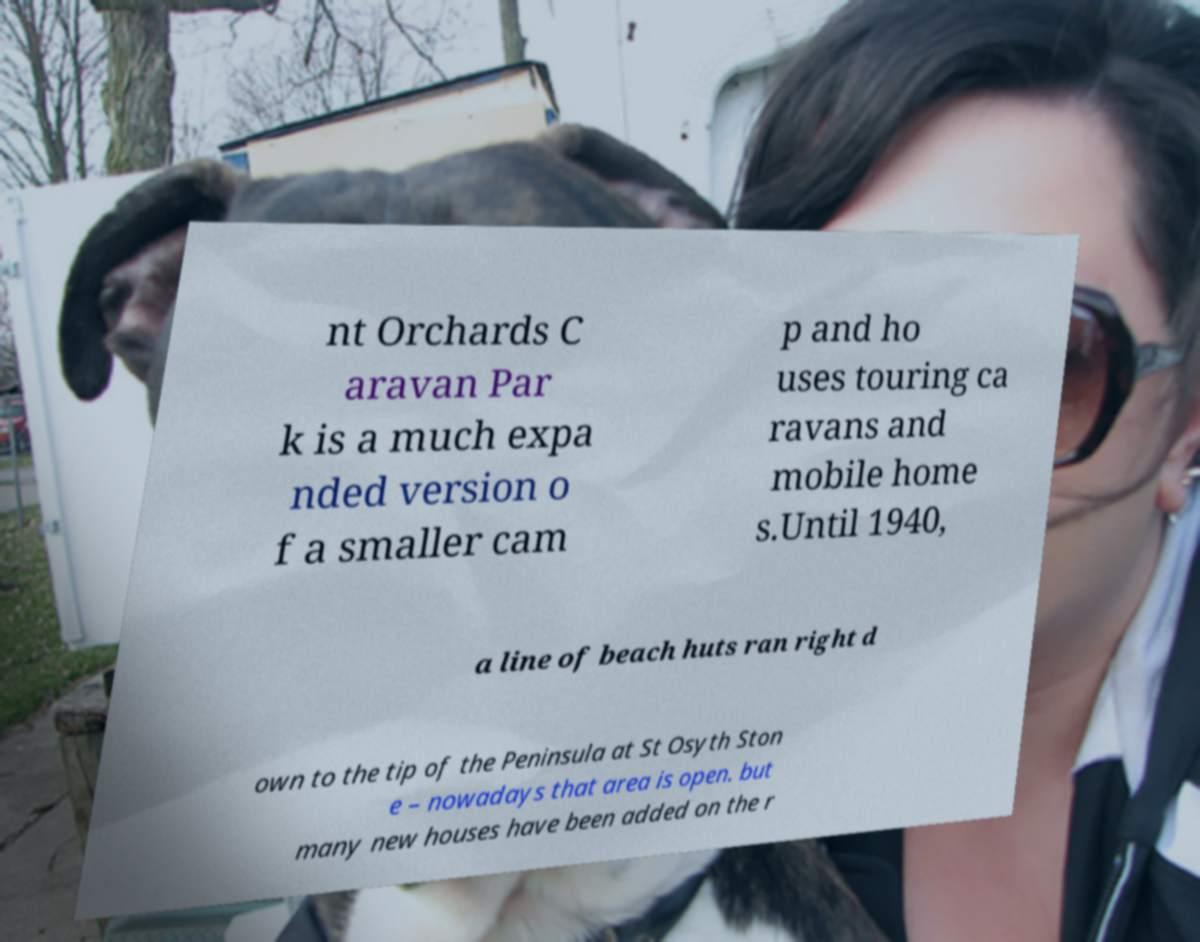Could you extract and type out the text from this image? nt Orchards C aravan Par k is a much expa nded version o f a smaller cam p and ho uses touring ca ravans and mobile home s.Until 1940, a line of beach huts ran right d own to the tip of the Peninsula at St Osyth Ston e – nowadays that area is open. but many new houses have been added on the r 